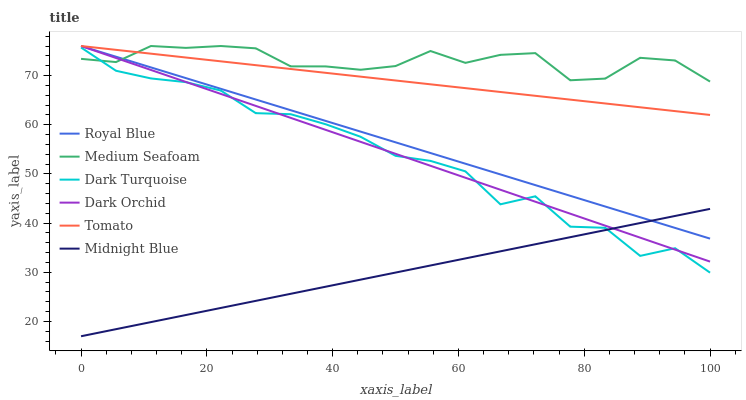Does Midnight Blue have the minimum area under the curve?
Answer yes or no. Yes. Does Medium Seafoam have the maximum area under the curve?
Answer yes or no. Yes. Does Dark Turquoise have the minimum area under the curve?
Answer yes or no. No. Does Dark Turquoise have the maximum area under the curve?
Answer yes or no. No. Is Royal Blue the smoothest?
Answer yes or no. Yes. Is Dark Turquoise the roughest?
Answer yes or no. Yes. Is Midnight Blue the smoothest?
Answer yes or no. No. Is Midnight Blue the roughest?
Answer yes or no. No. Does Midnight Blue have the lowest value?
Answer yes or no. Yes. Does Dark Turquoise have the lowest value?
Answer yes or no. No. Does Medium Seafoam have the highest value?
Answer yes or no. Yes. Does Dark Turquoise have the highest value?
Answer yes or no. No. Is Midnight Blue less than Tomato?
Answer yes or no. Yes. Is Tomato greater than Midnight Blue?
Answer yes or no. Yes. Does Dark Turquoise intersect Medium Seafoam?
Answer yes or no. Yes. Is Dark Turquoise less than Medium Seafoam?
Answer yes or no. No. Is Dark Turquoise greater than Medium Seafoam?
Answer yes or no. No. Does Midnight Blue intersect Tomato?
Answer yes or no. No. 